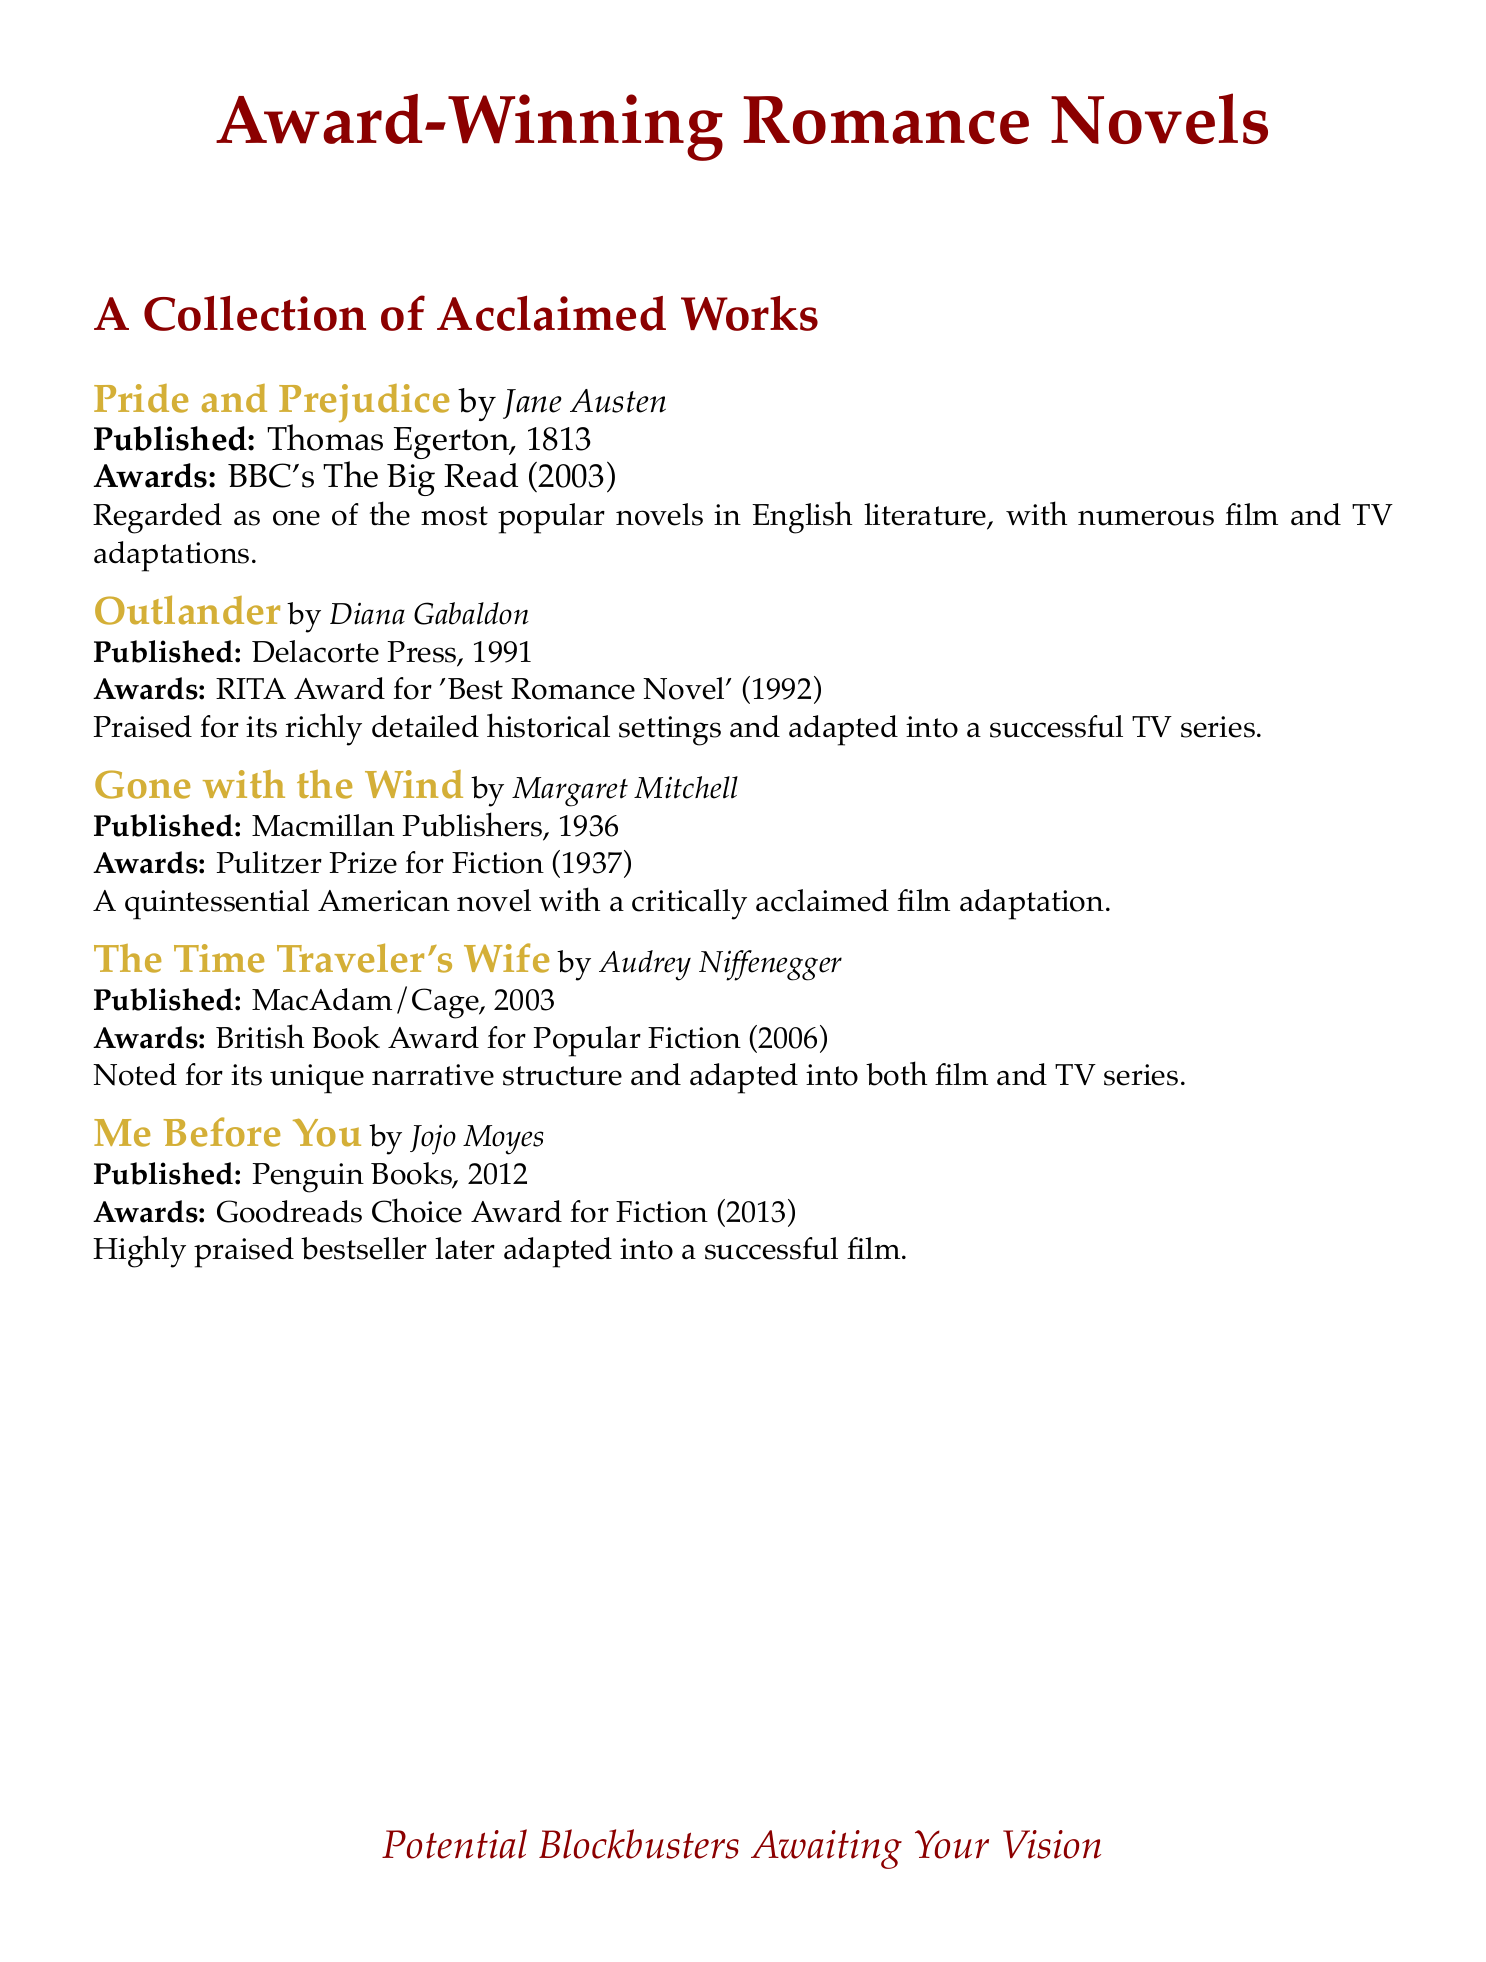What is the title of the first book listed? The first book listed is "Pride and Prejudice."
Answer: Pride and Prejudice Who is the author of "Me Before You"? The author of "Me Before You" is Jojo Moyes.
Answer: Jojo Moyes When was "Gone with the Wind" published? "Gone with the Wind" was published in 1936.
Answer: 1936 Which award did "Outlander" receive? "Outlander" received the RITA Award for 'Best Romance Novel' in 1992.
Answer: RITA Award for 'Best Romance Novel' (1992) What is a notable adaptation of "The Time Traveler's Wife"? "The Time Traveler's Wife" was adapted into both film and TV series.
Answer: Film and TV series Which book won the Pulitzer Prize for Fiction? The book that won the Pulitzer Prize for Fiction is "Gone with the Wind."
Answer: Gone with the Wind How many books are included in the collection? There are a total of five books included in the collection.
Answer: Five What year did "Me Before You" win the Goodreads Choice Award for Fiction? "Me Before You" won the Goodreads Choice Award for Fiction in 2013.
Answer: 2013 